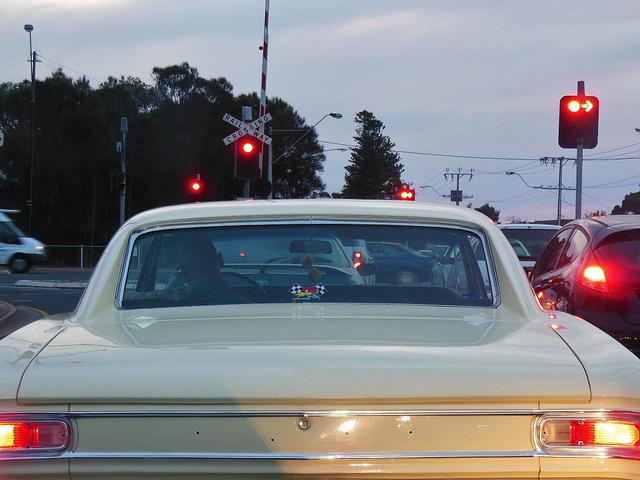There are a line of cars at the intersection because of what reason? train 